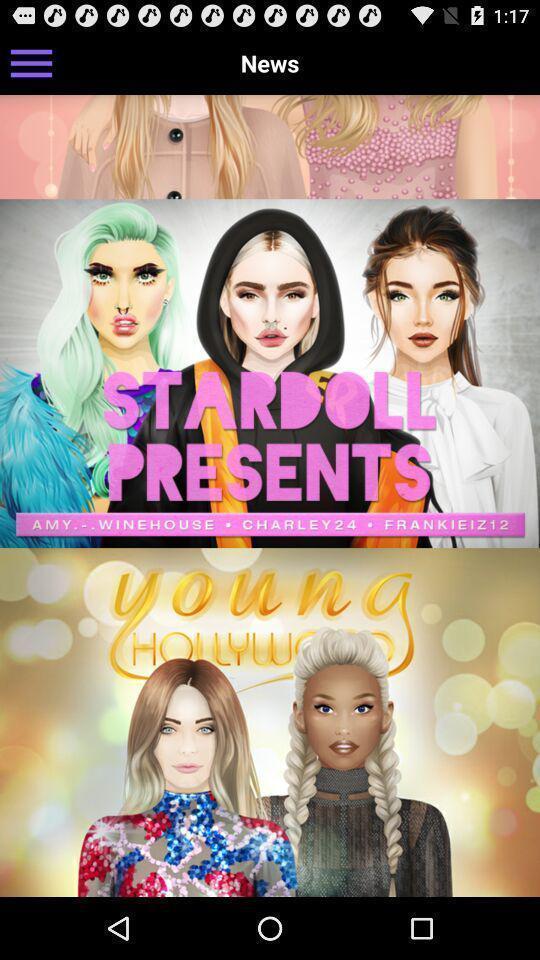Provide a description of this screenshot. Page that displaying cartoon application. 